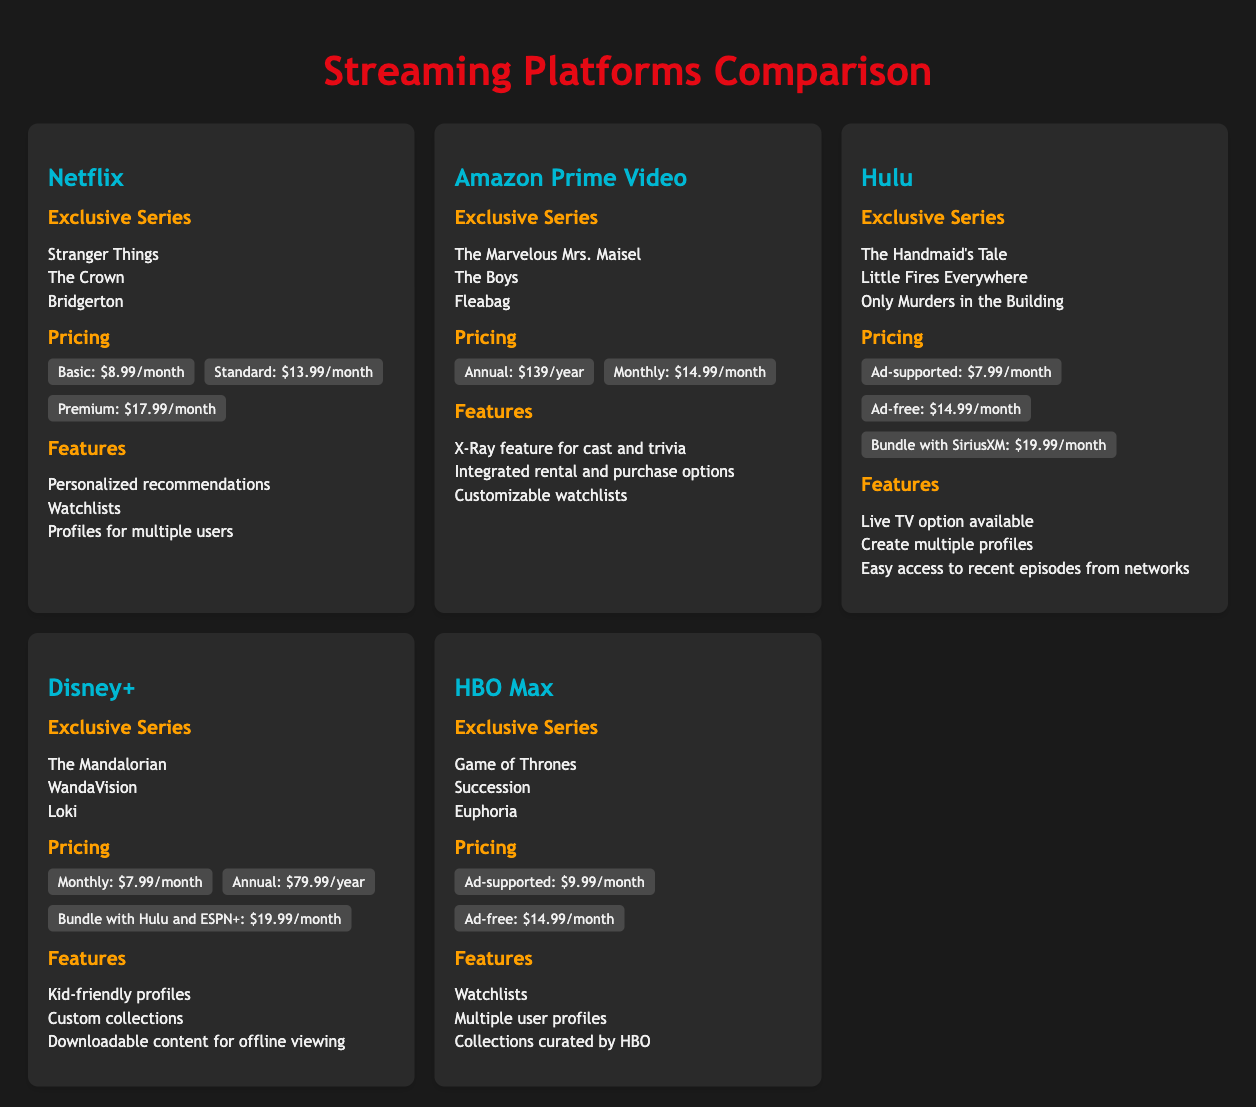What are the exclusive series on Netflix? The exclusive series listed under Netflix include Stranger Things, The Crown, and Bridgerton.
Answer: Stranger Things, The Crown, Bridgerton What is the monthly price for Hulu's ad-supported plan? The monthly price for Hulu's ad-supported plan is stated in the pricing section.
Answer: $7.99/month How many pricing tiers does Netflix offer? By reviewing the pricing section for Netflix, the number of tiers can be identified.
Answer: Three What unique feature does Amazon Prime Video offer? The section about features for Amazon Prime Video lists various unique features, one of which can be highlighted.
Answer: X-Ray feature for cast and trivia Which platform offers a bundle with Hulu and ESPN+? The pricing section for Disney+ indicates that there is an option for bundling with other services.
Answer: Disney+ What is the annual cost for Disney+? The pricing section provides specific information about the annual cost for Disney+.
Answer: $79.99/year How many exclusive series are listed under HBO Max? By counting the exclusive series under HBO Max in the document, we can find the answer.
Answer: Three What is a feature available on Disney+? The features listed under Disney+ include a specific option that can be directly quoted.
Answer: Kid-friendly profiles 